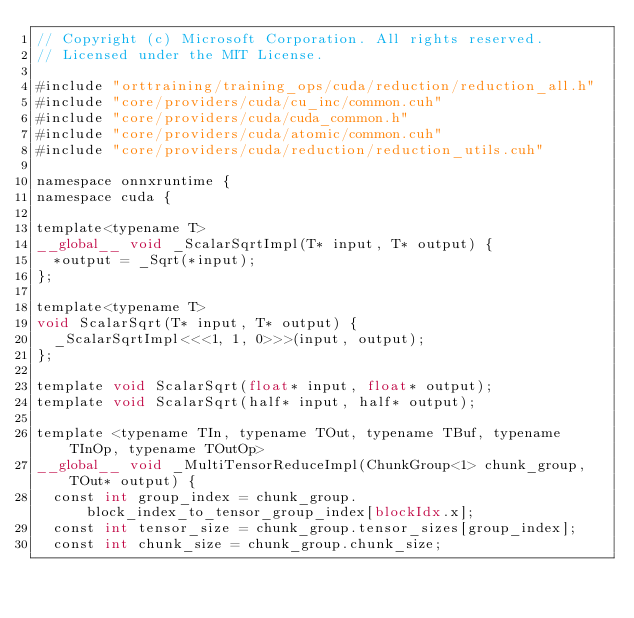<code> <loc_0><loc_0><loc_500><loc_500><_Cuda_>// Copyright (c) Microsoft Corporation. All rights reserved.
// Licensed under the MIT License.

#include "orttraining/training_ops/cuda/reduction/reduction_all.h"
#include "core/providers/cuda/cu_inc/common.cuh"
#include "core/providers/cuda/cuda_common.h"
#include "core/providers/cuda/atomic/common.cuh"
#include "core/providers/cuda/reduction/reduction_utils.cuh"

namespace onnxruntime {
namespace cuda {

template<typename T>
__global__ void _ScalarSqrtImpl(T* input, T* output) {
  *output = _Sqrt(*input);
};

template<typename T>
void ScalarSqrt(T* input, T* output) {
  _ScalarSqrtImpl<<<1, 1, 0>>>(input, output);
};

template void ScalarSqrt(float* input, float* output);
template void ScalarSqrt(half* input, half* output);

template <typename TIn, typename TOut, typename TBuf, typename TInOp, typename TOutOp>
__global__ void _MultiTensorReduceImpl(ChunkGroup<1> chunk_group, TOut* output) {
  const int group_index = chunk_group.block_index_to_tensor_group_index[blockIdx.x];
  const int tensor_size = chunk_group.tensor_sizes[group_index];
  const int chunk_size = chunk_group.chunk_size;</code> 